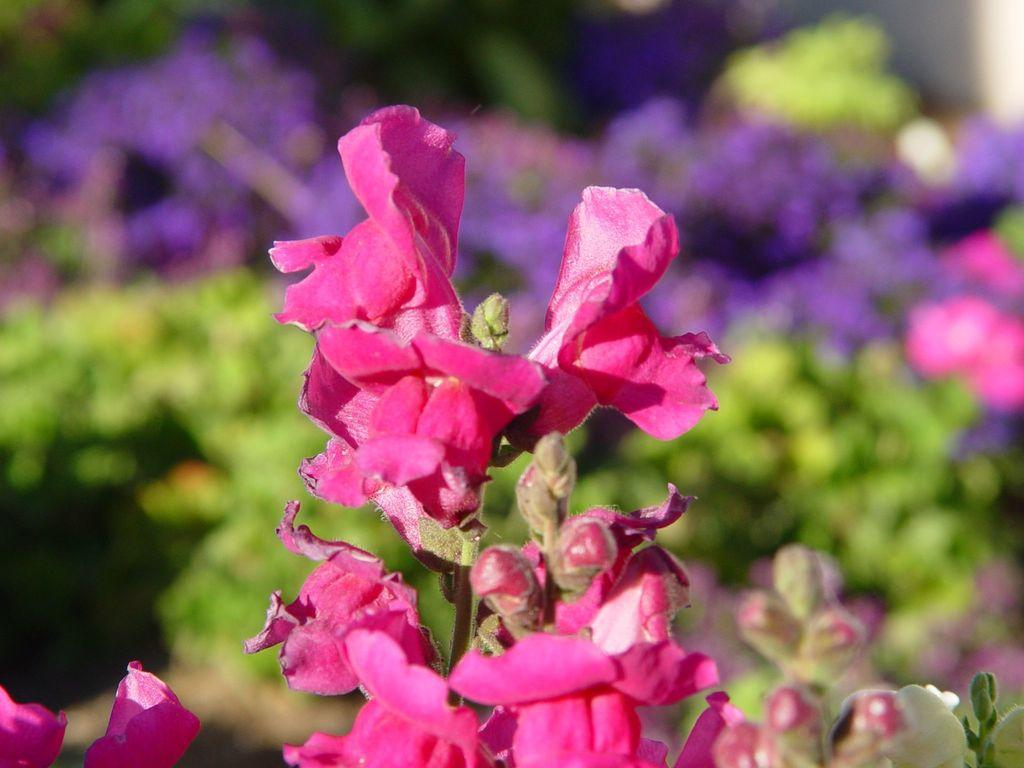What type of flowers are in the image? There is a bunch of pink flowers in the image. What stage of growth are the flowers in? The flowers have buds on them. Can you describe the background of the image? The background of the image is blurry. How many cabbages can be seen in the image? There are no cabbages present in the image; it features a bunch of pink flowers. Is there a person visible in the image? There is no person visible in the image. 